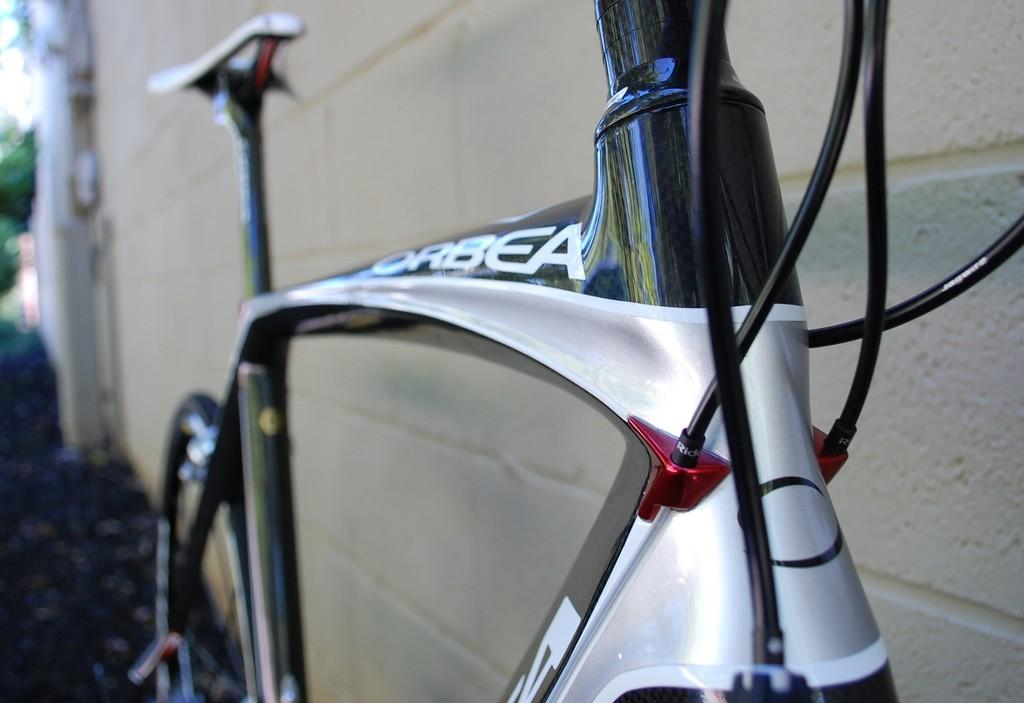What is the main object in the image? There is a bicycle in the image. What feature can be seen on the bicycle? The bicycle has cables. How is the bicycle positioned in the image? The bicycle is placed on the ground. What can be seen in the background of the image? There is a building, a tree, and the sky visible in the background of the image. How many ducks are flying in the sky in the image? There are no ducks visible in the image; it features a bicycle with cables, placed on the ground, and a background with a building, a tree, and the sky. 